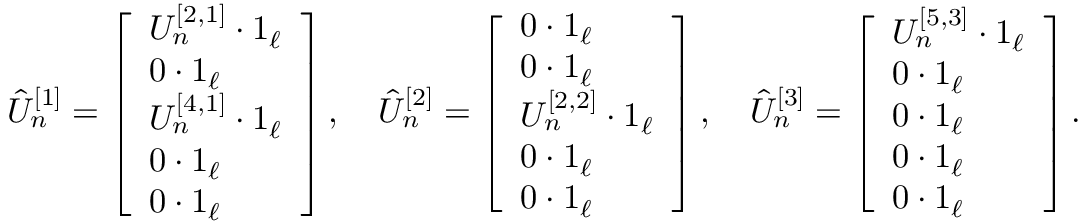<formula> <loc_0><loc_0><loc_500><loc_500>\begin{array} { r } { \hat { U } _ { n } ^ { [ 1 ] } = \left [ \begin{array} { l } { U _ { n } ^ { [ 2 , 1 ] } \cdot 1 _ { \ell } } \\ { 0 \cdot 1 _ { \ell } } \\ { U _ { n } ^ { [ 4 , 1 ] } \cdot 1 _ { \ell } } \\ { 0 \cdot 1 _ { \ell } } \\ { 0 \cdot 1 _ { \ell } } \end{array} \right ] , \quad \hat { U } _ { n } ^ { [ 2 ] } = \left [ \begin{array} { l } { 0 \cdot 1 _ { \ell } } \\ { 0 \cdot 1 _ { \ell } } \\ { U _ { n } ^ { [ 2 , 2 ] } \cdot 1 _ { \ell } } \\ { 0 \cdot 1 _ { \ell } } \\ { 0 \cdot 1 _ { \ell } } \end{array} \right ] , \quad \hat { U } _ { n } ^ { [ 3 ] } = \left [ \begin{array} { l } { U _ { n } ^ { [ 5 , 3 ] } \cdot 1 _ { \ell } } \\ { 0 \cdot 1 _ { \ell } } \\ { 0 \cdot 1 _ { \ell } } \\ { 0 \cdot 1 _ { \ell } } \\ { 0 \cdot 1 _ { \ell } } \end{array} \right ] . } \end{array}</formula> 